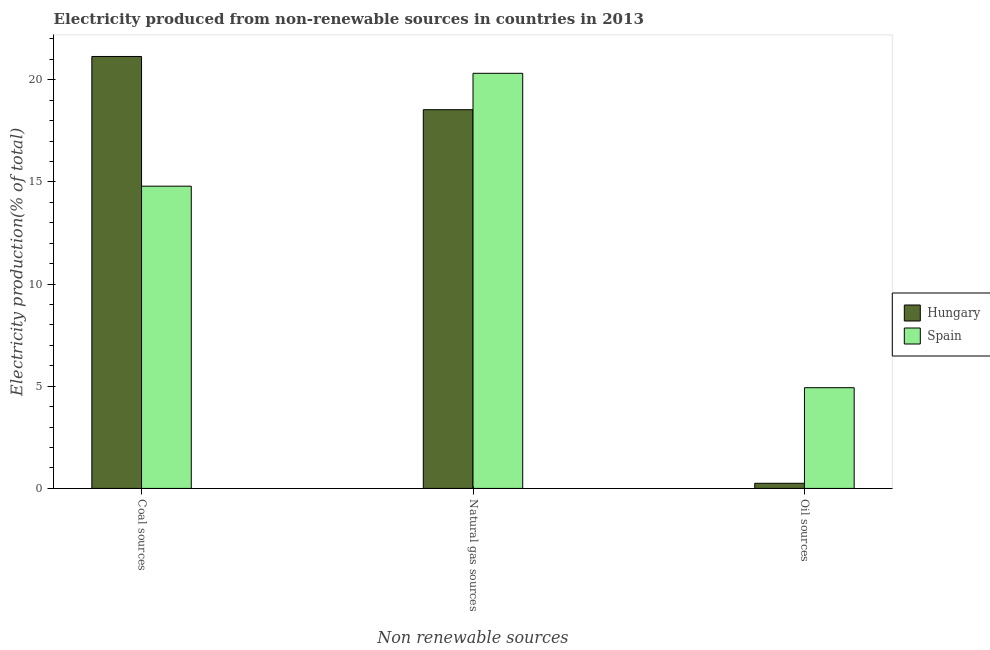How many different coloured bars are there?
Your answer should be compact. 2. How many groups of bars are there?
Your response must be concise. 3. How many bars are there on the 3rd tick from the left?
Offer a very short reply. 2. How many bars are there on the 3rd tick from the right?
Provide a short and direct response. 2. What is the label of the 3rd group of bars from the left?
Offer a very short reply. Oil sources. What is the percentage of electricity produced by natural gas in Hungary?
Make the answer very short. 18.54. Across all countries, what is the maximum percentage of electricity produced by coal?
Offer a terse response. 21.14. Across all countries, what is the minimum percentage of electricity produced by coal?
Provide a short and direct response. 14.8. In which country was the percentage of electricity produced by coal maximum?
Offer a very short reply. Hungary. What is the total percentage of electricity produced by natural gas in the graph?
Make the answer very short. 38.86. What is the difference between the percentage of electricity produced by oil sources in Spain and that in Hungary?
Give a very brief answer. 4.68. What is the difference between the percentage of electricity produced by natural gas in Spain and the percentage of electricity produced by coal in Hungary?
Offer a very short reply. -0.82. What is the average percentage of electricity produced by natural gas per country?
Make the answer very short. 19.43. What is the difference between the percentage of electricity produced by natural gas and percentage of electricity produced by coal in Hungary?
Provide a short and direct response. -2.61. What is the ratio of the percentage of electricity produced by oil sources in Hungary to that in Spain?
Offer a very short reply. 0.05. Is the percentage of electricity produced by oil sources in Spain less than that in Hungary?
Offer a very short reply. No. Is the difference between the percentage of electricity produced by coal in Spain and Hungary greater than the difference between the percentage of electricity produced by oil sources in Spain and Hungary?
Give a very brief answer. No. What is the difference between the highest and the second highest percentage of electricity produced by coal?
Keep it short and to the point. 6.35. What is the difference between the highest and the lowest percentage of electricity produced by natural gas?
Your answer should be very brief. 1.78. What does the 1st bar from the right in Oil sources represents?
Ensure brevity in your answer.  Spain. Is it the case that in every country, the sum of the percentage of electricity produced by coal and percentage of electricity produced by natural gas is greater than the percentage of electricity produced by oil sources?
Provide a short and direct response. Yes. How many bars are there?
Provide a succinct answer. 6. Are all the bars in the graph horizontal?
Provide a succinct answer. No. What is the difference between two consecutive major ticks on the Y-axis?
Ensure brevity in your answer.  5. Does the graph contain grids?
Keep it short and to the point. No. What is the title of the graph?
Your response must be concise. Electricity produced from non-renewable sources in countries in 2013. Does "High income: nonOECD" appear as one of the legend labels in the graph?
Ensure brevity in your answer.  No. What is the label or title of the X-axis?
Offer a very short reply. Non renewable sources. What is the label or title of the Y-axis?
Provide a short and direct response. Electricity production(% of total). What is the Electricity production(% of total) in Hungary in Coal sources?
Offer a terse response. 21.14. What is the Electricity production(% of total) in Spain in Coal sources?
Offer a terse response. 14.8. What is the Electricity production(% of total) of Hungary in Natural gas sources?
Offer a very short reply. 18.54. What is the Electricity production(% of total) of Spain in Natural gas sources?
Make the answer very short. 20.32. What is the Electricity production(% of total) in Hungary in Oil sources?
Keep it short and to the point. 0.25. What is the Electricity production(% of total) in Spain in Oil sources?
Offer a terse response. 4.93. Across all Non renewable sources, what is the maximum Electricity production(% of total) in Hungary?
Offer a very short reply. 21.14. Across all Non renewable sources, what is the maximum Electricity production(% of total) in Spain?
Give a very brief answer. 20.32. Across all Non renewable sources, what is the minimum Electricity production(% of total) of Hungary?
Provide a short and direct response. 0.25. Across all Non renewable sources, what is the minimum Electricity production(% of total) of Spain?
Make the answer very short. 4.93. What is the total Electricity production(% of total) of Hungary in the graph?
Offer a very short reply. 39.93. What is the total Electricity production(% of total) in Spain in the graph?
Provide a short and direct response. 40.05. What is the difference between the Electricity production(% of total) in Hungary in Coal sources and that in Natural gas sources?
Ensure brevity in your answer.  2.61. What is the difference between the Electricity production(% of total) in Spain in Coal sources and that in Natural gas sources?
Provide a short and direct response. -5.52. What is the difference between the Electricity production(% of total) in Hungary in Coal sources and that in Oil sources?
Make the answer very short. 20.89. What is the difference between the Electricity production(% of total) of Spain in Coal sources and that in Oil sources?
Give a very brief answer. 9.87. What is the difference between the Electricity production(% of total) in Hungary in Natural gas sources and that in Oil sources?
Make the answer very short. 18.29. What is the difference between the Electricity production(% of total) of Spain in Natural gas sources and that in Oil sources?
Your response must be concise. 15.39. What is the difference between the Electricity production(% of total) of Hungary in Coal sources and the Electricity production(% of total) of Spain in Natural gas sources?
Your answer should be compact. 0.82. What is the difference between the Electricity production(% of total) of Hungary in Coal sources and the Electricity production(% of total) of Spain in Oil sources?
Your answer should be very brief. 16.21. What is the difference between the Electricity production(% of total) in Hungary in Natural gas sources and the Electricity production(% of total) in Spain in Oil sources?
Make the answer very short. 13.61. What is the average Electricity production(% of total) of Hungary per Non renewable sources?
Keep it short and to the point. 13.31. What is the average Electricity production(% of total) of Spain per Non renewable sources?
Your answer should be compact. 13.35. What is the difference between the Electricity production(% of total) of Hungary and Electricity production(% of total) of Spain in Coal sources?
Your response must be concise. 6.35. What is the difference between the Electricity production(% of total) in Hungary and Electricity production(% of total) in Spain in Natural gas sources?
Ensure brevity in your answer.  -1.78. What is the difference between the Electricity production(% of total) in Hungary and Electricity production(% of total) in Spain in Oil sources?
Keep it short and to the point. -4.68. What is the ratio of the Electricity production(% of total) of Hungary in Coal sources to that in Natural gas sources?
Your response must be concise. 1.14. What is the ratio of the Electricity production(% of total) of Spain in Coal sources to that in Natural gas sources?
Ensure brevity in your answer.  0.73. What is the ratio of the Electricity production(% of total) of Hungary in Coal sources to that in Oil sources?
Offer a terse response. 84.34. What is the ratio of the Electricity production(% of total) of Spain in Coal sources to that in Oil sources?
Make the answer very short. 3. What is the ratio of the Electricity production(% of total) of Hungary in Natural gas sources to that in Oil sources?
Provide a short and direct response. 73.95. What is the ratio of the Electricity production(% of total) of Spain in Natural gas sources to that in Oil sources?
Your response must be concise. 4.12. What is the difference between the highest and the second highest Electricity production(% of total) in Hungary?
Offer a terse response. 2.61. What is the difference between the highest and the second highest Electricity production(% of total) in Spain?
Offer a very short reply. 5.52. What is the difference between the highest and the lowest Electricity production(% of total) in Hungary?
Give a very brief answer. 20.89. What is the difference between the highest and the lowest Electricity production(% of total) of Spain?
Offer a very short reply. 15.39. 